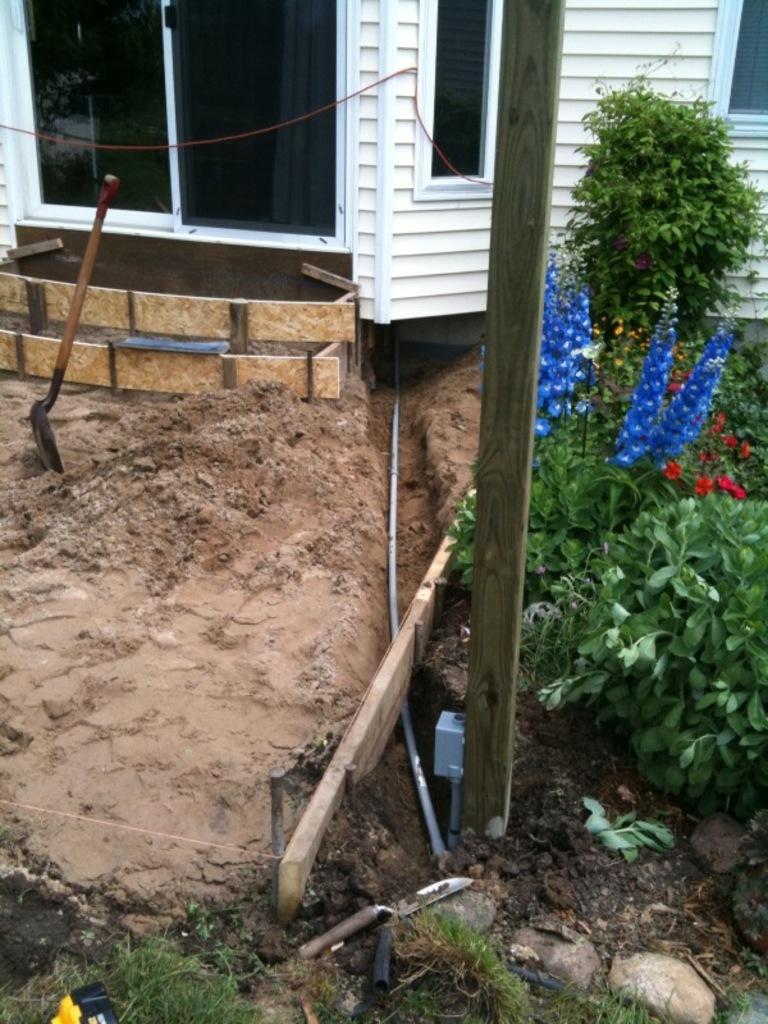Describe this image in one or two sentences. In this image we can see plants with flowers, pipe, digging tool, objects, sand, wooden pole, wall, windows, glasses and other objects. 